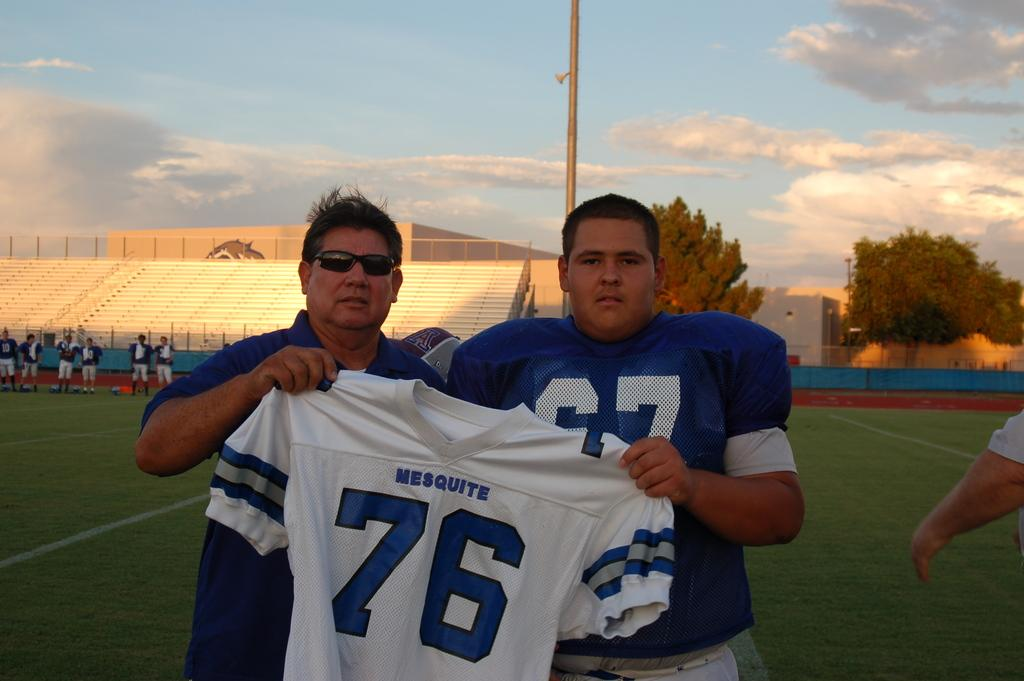<image>
Create a compact narrative representing the image presented. Two guys are holding up a jersey with the number 76 on it. 